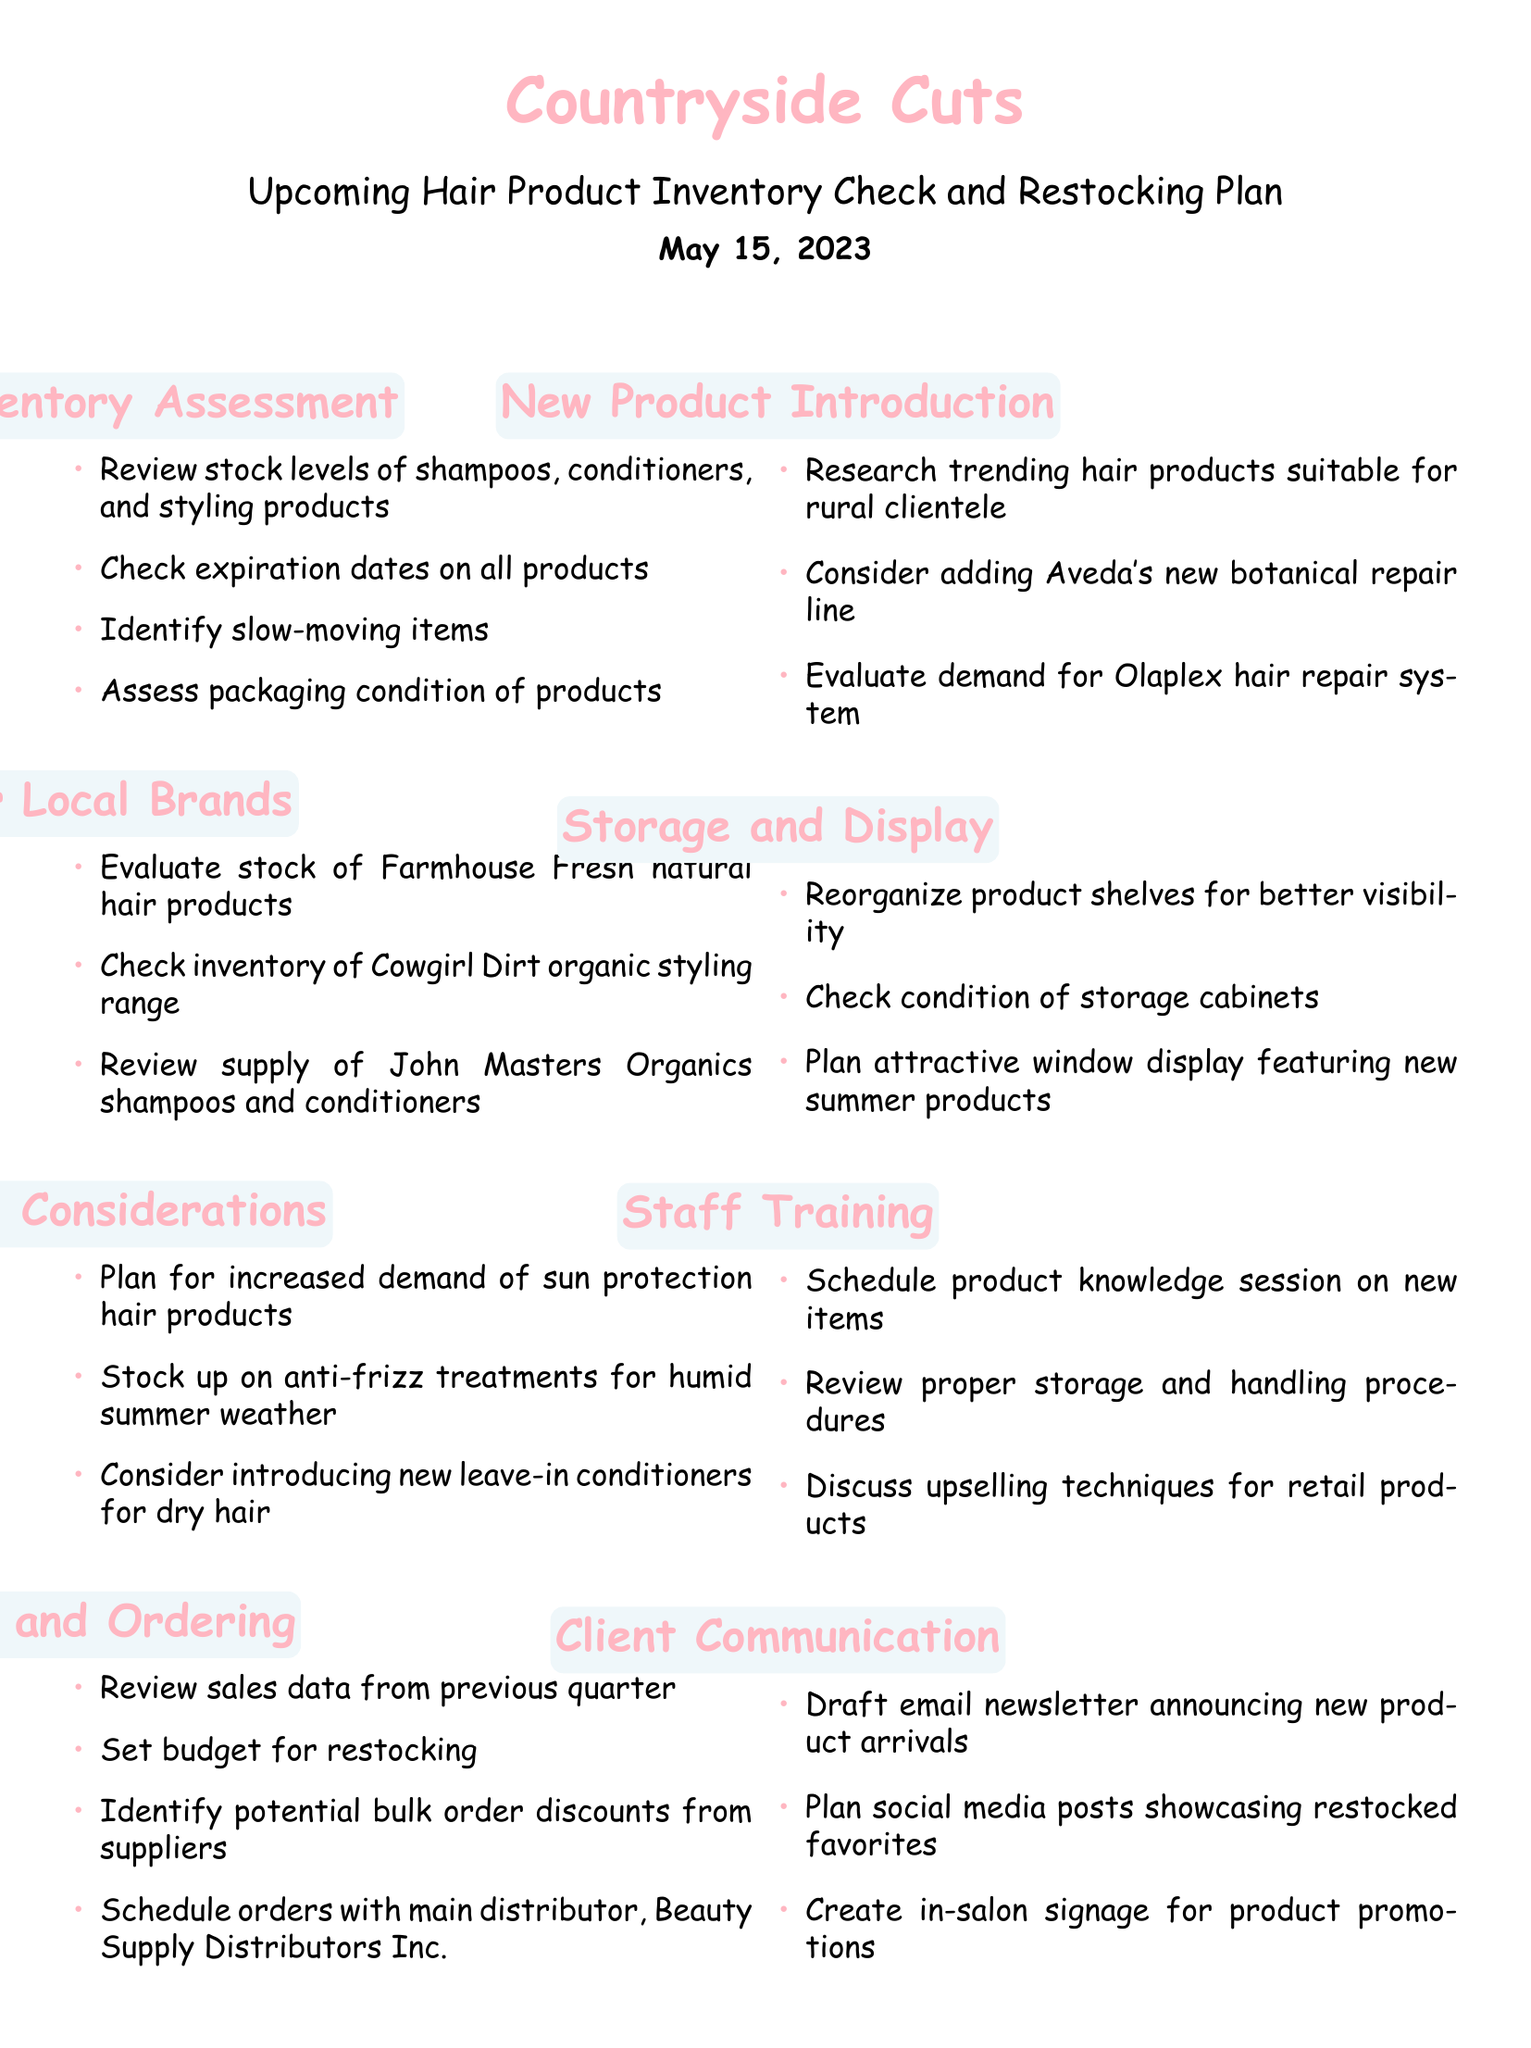What is the name of the salon? The salon's name is stated at the beginning of the document.
Answer: Countryside Cuts When is the inventory check date? The inventory check date is clearly mentioned in the document.
Answer: May 15, 2023 What is one of the popular local brands listed? Popular local brands are mentioned in a specific section.
Answer: Farmhouse Fresh What product type is considered for increased demand? The document identifies specific product types planned for increased demand during a season.
Answer: Sun protection hair products Who is the main distributor mentioned? The document specifies the main distributor for ordering supplies.
Answer: Beauty Supply Distributors Inc What should be included in client communication? The document outlines items to be included in client communication efforts.
Answer: Email newsletter How many items are in the storage and display section? The document lists items in the storage and display section.
Answer: Three What is being evaluated in the new product introduction section? The document indicates specific criteria under new product introduction.
Answer: Trending hair products What should be scheduled for staff training? Staff training items are explicitly mentioned in the document.
Answer: Product knowledge session 